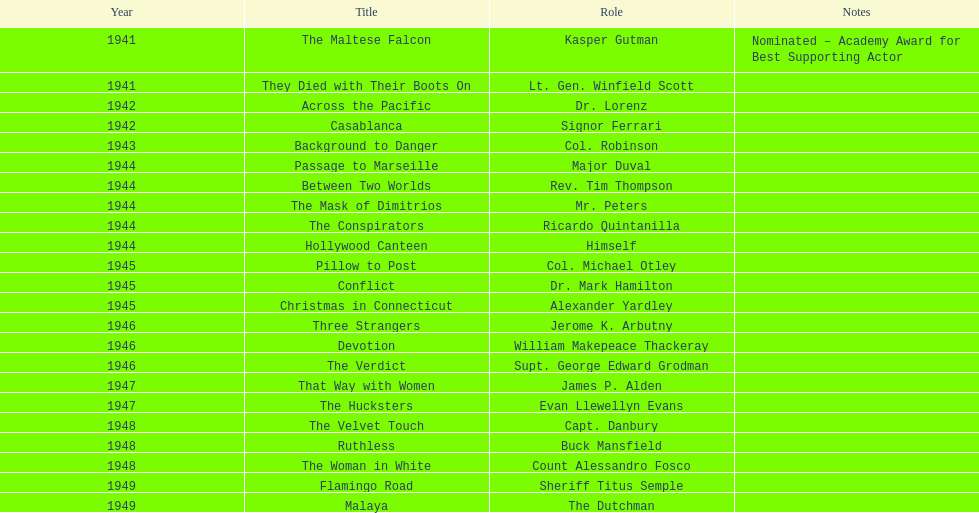In which films did greenstreet make his first and last appearances as an actor? The Maltese Falcon, Malaya. 